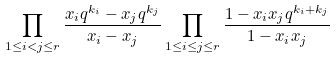<formula> <loc_0><loc_0><loc_500><loc_500>\prod _ { 1 \leq i < j \leq r } \frac { x _ { i } q ^ { k _ { i } } - x _ { j } q ^ { k _ { j } } } { x _ { i } - x _ { j } } \prod _ { 1 \leq i \leq j \leq r } \frac { 1 - x _ { i } x _ { j } q ^ { k _ { i } + k _ { j } } } { 1 - x _ { i } x _ { j } }</formula> 